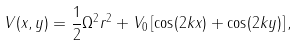Convert formula to latex. <formula><loc_0><loc_0><loc_500><loc_500>V ( x , y ) = \frac { 1 } { 2 } \Omega ^ { 2 } r ^ { 2 } + V _ { 0 } \left [ \cos ( 2 k x ) + \cos ( 2 k y ) \right ] ,</formula> 